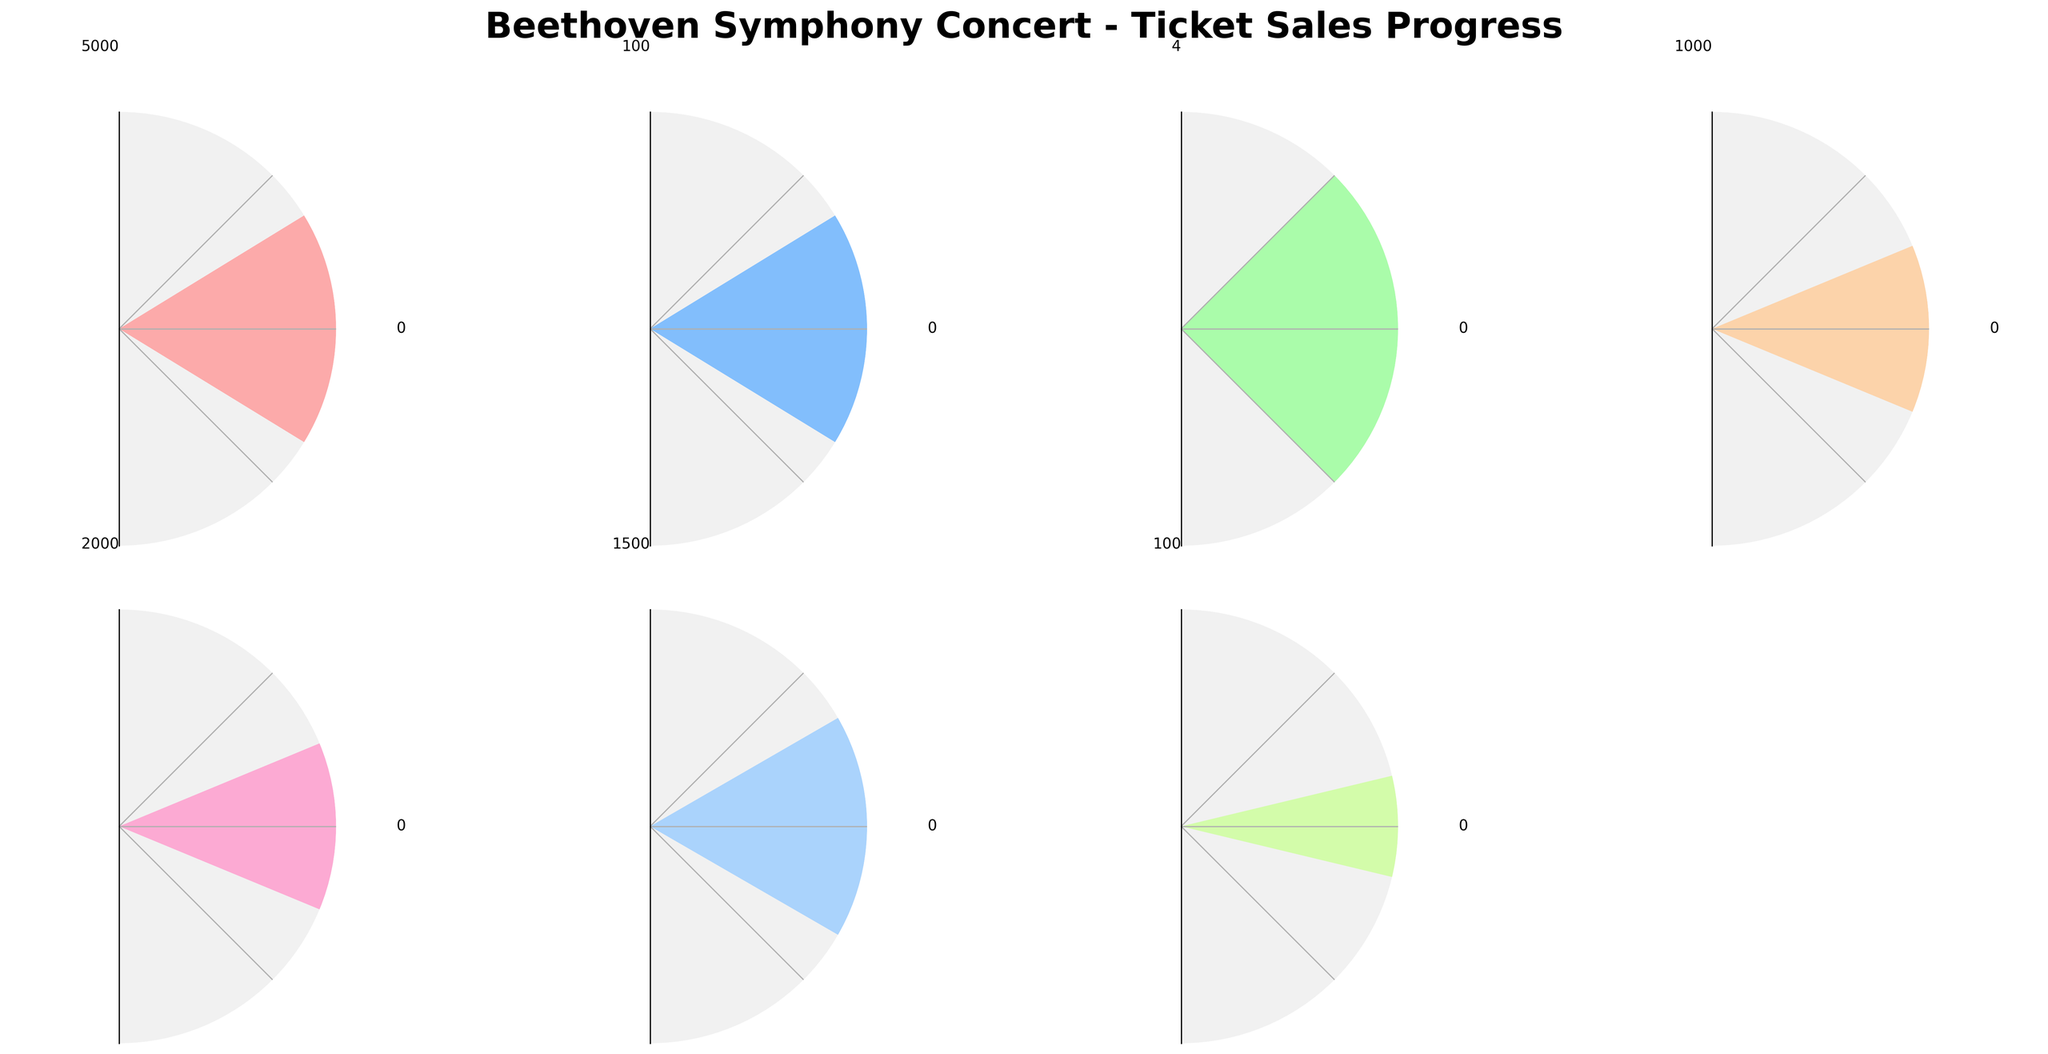What is the title of the figure? The title is located at the top of the figure, usually in a larger and bold font. It reads "Beethoven Symphony Concert - Ticket Sales Progress".
Answer: Beethoven Symphony Concert - Ticket Sales Progress How many weeks are left until the concert? The gauge chart labeled "Weeks Until Concert" provides this information. The needle points to 2 weeks.
Answer: 2 How many VIP seats have been sold? Check the gauge labeled "VIP Seats Sold". The needle in this gauge indicates the value 750.
Answer: 750 What's the percentage of tickets sold? Look at the gauge labeled "Percentage Sold". The needle points to 65%.
Answer: 65% Are more regular seats sold than balcony seats? Compare the values in the gauges labeled "Regular Seats Sold" and "Balcony Seats Sold". Regular seats sold are 1500, whereas balcony seats sold are 1000.
Answer: Yes What's the range of VIP seats that could be sold? The minimum and maximum values on the gauge for "VIP Seats Sold" indicate a range from 0 to 1000.
Answer: 0 to 1000 Which gauge shows the highest maximum value possible? Compare the maximum values indicated on all gauges. The "Regular Seats Sold" gauge has the highest maximum value of 2000.
Answer: Regular Seats Sold What percentage of the target revenue has been achieved? The gauge labeled "Percentage of Target Revenue" shows that 85% of the target revenue has been achieved.
Answer: 85% What is the difference between the number of regular seats sold and the number of balcony seats sold? Subtract the number of balcony seats sold (1000) from the number of regular seats sold (1500). 1500 - 1000 = 500.
Answer: 500 Summarize how ticket sales are progressing overall. The "Tickets Sold" value is 3250 out of a maximum of 5000, corresponding to 65% of tickets sold. There are 2 weeks left, and the percentage of target revenue achieved is at 85%. VIP and Regular seats are selling well, while Balcony seats have fewer sales. This indicates good progress overall but suggests a need to boost Balcony seat sales.
Answer: Good progress overall 